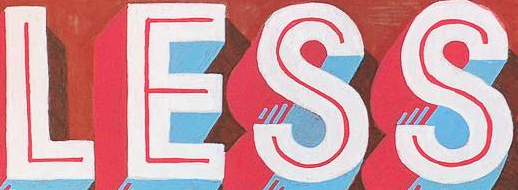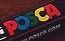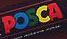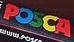Transcribe the words shown in these images in order, separated by a semicolon. LESS; POSCA; POSCA; POSCA 